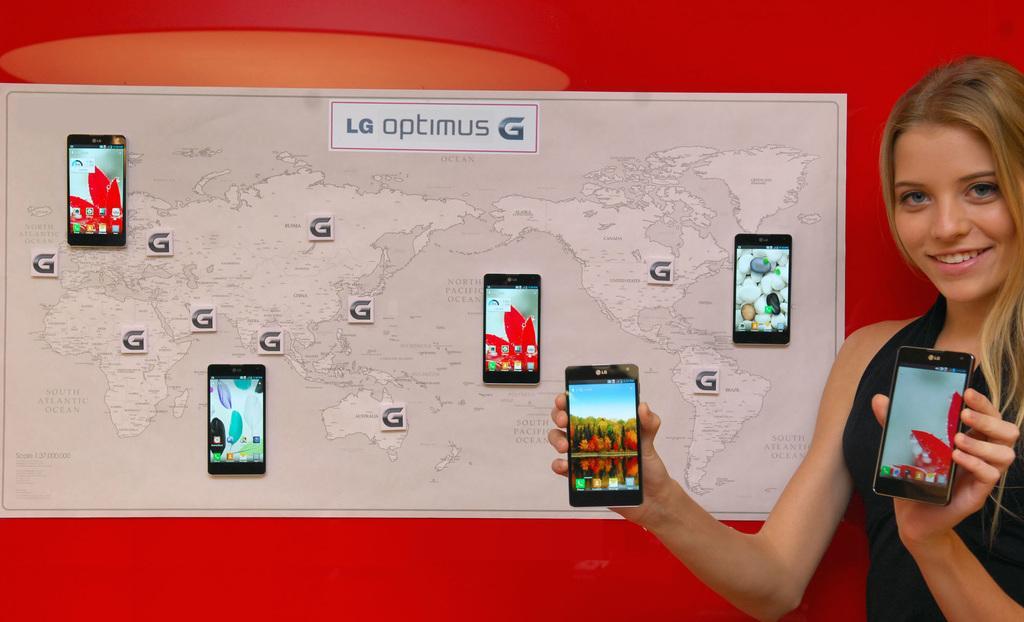How would you summarize this image in a sentence or two? In this image we can see a woman holding the mobile phones. On the backside we can see the pictures of mobile phone, a map and some text on a paper which is pasted on the wall. 